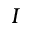<formula> <loc_0><loc_0><loc_500><loc_500>I</formula> 